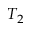Convert formula to latex. <formula><loc_0><loc_0><loc_500><loc_500>T _ { 2 }</formula> 